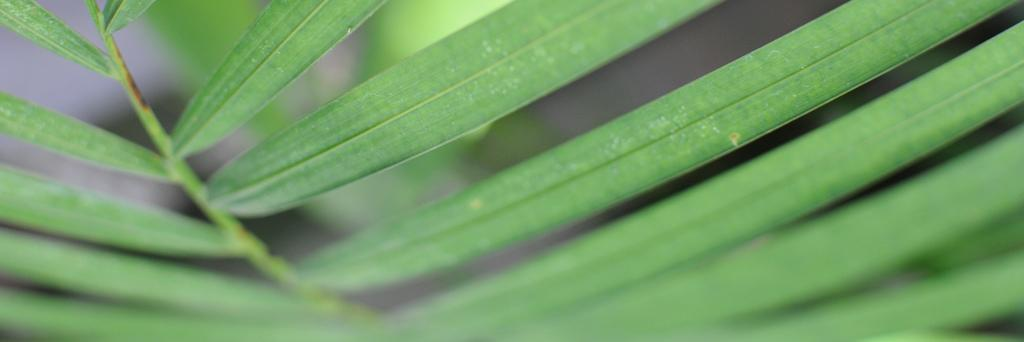What type of vegetation can be seen in the image? There are leaves in the image. Can you describe the background of the image? The background of the image is blurred. Is there a squirrel rolling a thing in the image? There is no squirrel or any object being rolled in the image; it only features leaves and a blurred background. 